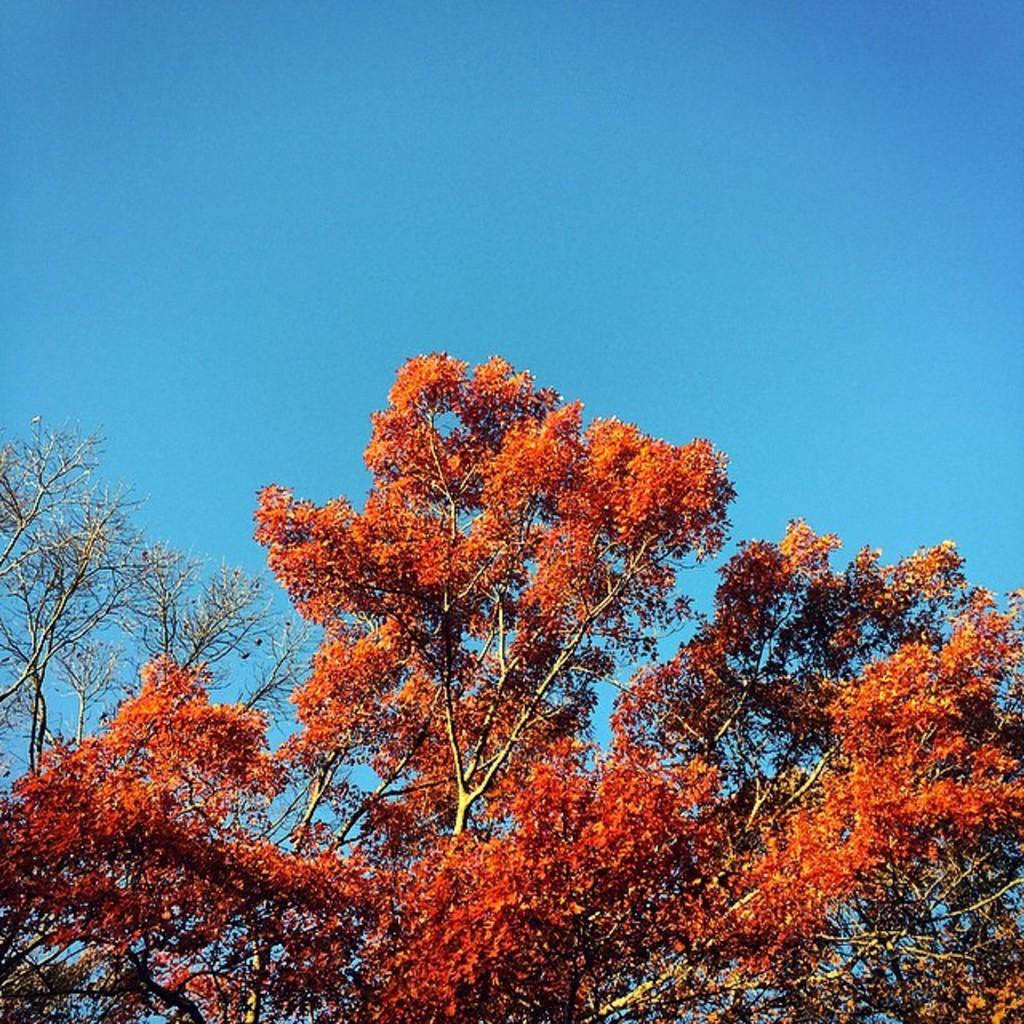What type of vegetation can be seen in the image? There are trees in the image. What features do the trees have? The trees have branches and leaves. What color are the leaves on the trees? The leaves are light reddish in color. What type of approval is the governor seeking in the image? There is no reference to a governor or approval in the image; it features trees with light reddish leaves. 